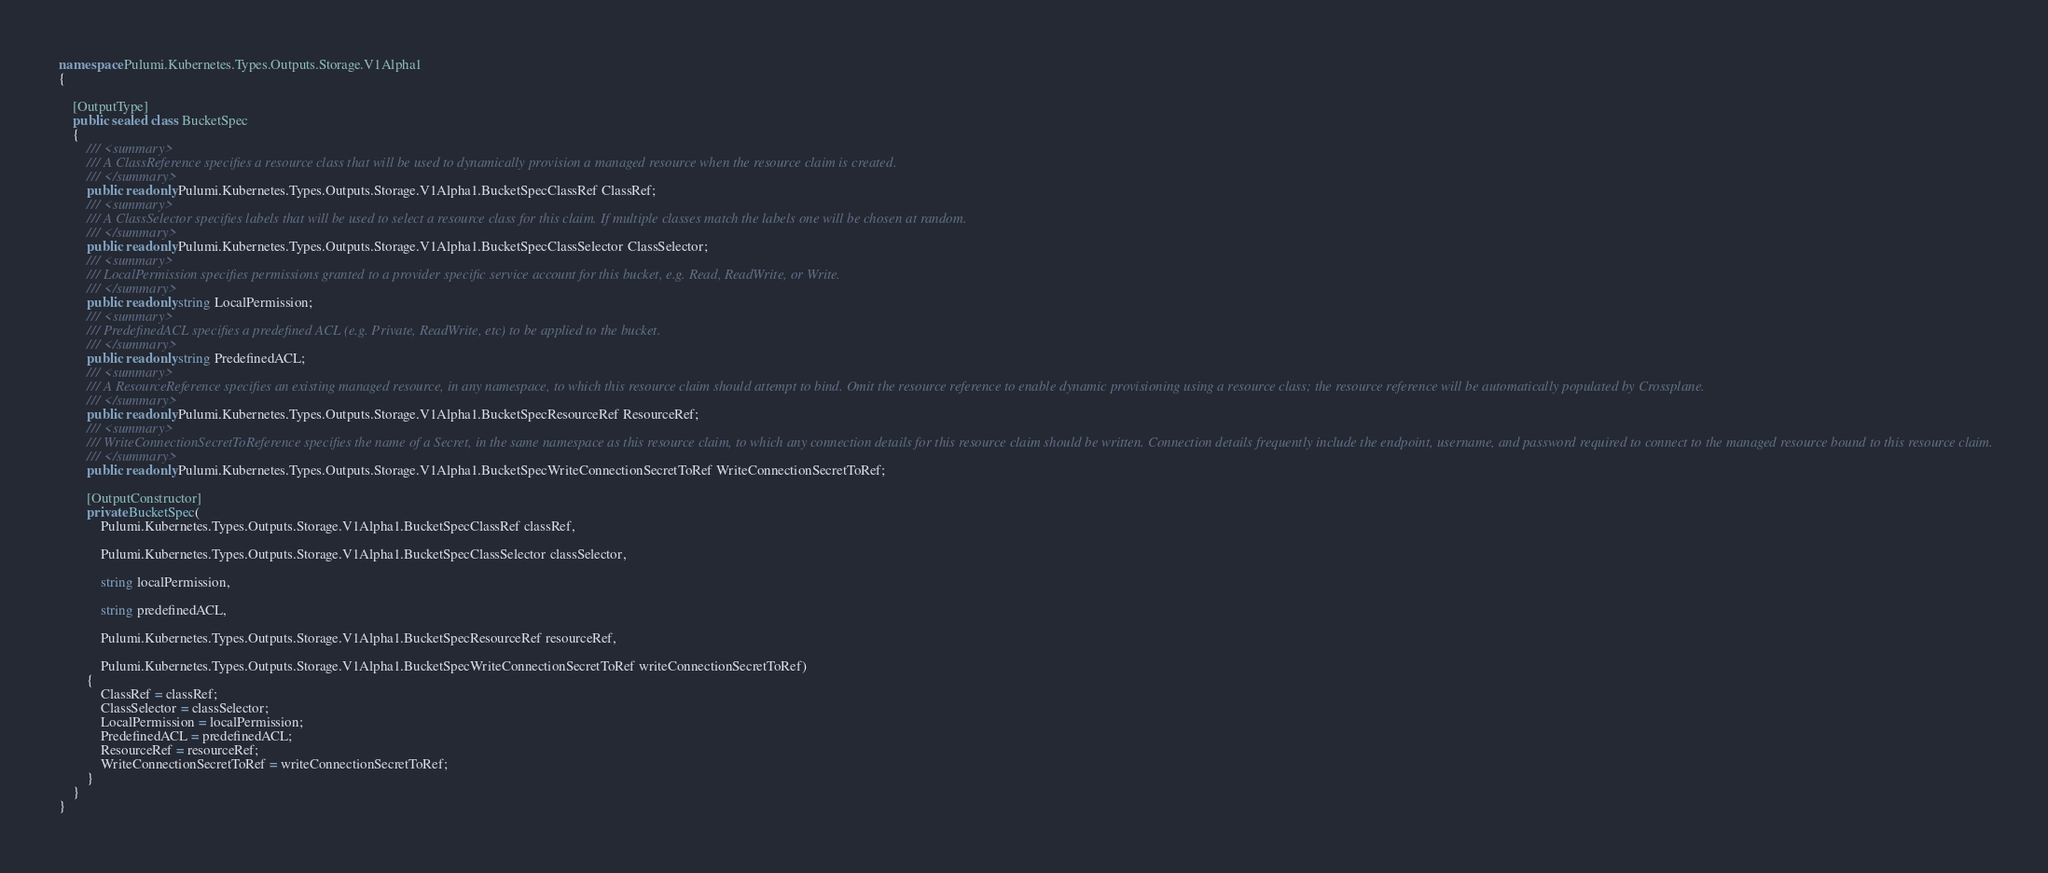<code> <loc_0><loc_0><loc_500><loc_500><_C#_>namespace Pulumi.Kubernetes.Types.Outputs.Storage.V1Alpha1
{

    [OutputType]
    public sealed class BucketSpec
    {
        /// <summary>
        /// A ClassReference specifies a resource class that will be used to dynamically provision a managed resource when the resource claim is created.
        /// </summary>
        public readonly Pulumi.Kubernetes.Types.Outputs.Storage.V1Alpha1.BucketSpecClassRef ClassRef;
        /// <summary>
        /// A ClassSelector specifies labels that will be used to select a resource class for this claim. If multiple classes match the labels one will be chosen at random.
        /// </summary>
        public readonly Pulumi.Kubernetes.Types.Outputs.Storage.V1Alpha1.BucketSpecClassSelector ClassSelector;
        /// <summary>
        /// LocalPermission specifies permissions granted to a provider specific service account for this bucket, e.g. Read, ReadWrite, or Write.
        /// </summary>
        public readonly string LocalPermission;
        /// <summary>
        /// PredefinedACL specifies a predefined ACL (e.g. Private, ReadWrite, etc) to be applied to the bucket.
        /// </summary>
        public readonly string PredefinedACL;
        /// <summary>
        /// A ResourceReference specifies an existing managed resource, in any namespace, to which this resource claim should attempt to bind. Omit the resource reference to enable dynamic provisioning using a resource class; the resource reference will be automatically populated by Crossplane.
        /// </summary>
        public readonly Pulumi.Kubernetes.Types.Outputs.Storage.V1Alpha1.BucketSpecResourceRef ResourceRef;
        /// <summary>
        /// WriteConnectionSecretToReference specifies the name of a Secret, in the same namespace as this resource claim, to which any connection details for this resource claim should be written. Connection details frequently include the endpoint, username, and password required to connect to the managed resource bound to this resource claim.
        /// </summary>
        public readonly Pulumi.Kubernetes.Types.Outputs.Storage.V1Alpha1.BucketSpecWriteConnectionSecretToRef WriteConnectionSecretToRef;

        [OutputConstructor]
        private BucketSpec(
            Pulumi.Kubernetes.Types.Outputs.Storage.V1Alpha1.BucketSpecClassRef classRef,

            Pulumi.Kubernetes.Types.Outputs.Storage.V1Alpha1.BucketSpecClassSelector classSelector,

            string localPermission,

            string predefinedACL,

            Pulumi.Kubernetes.Types.Outputs.Storage.V1Alpha1.BucketSpecResourceRef resourceRef,

            Pulumi.Kubernetes.Types.Outputs.Storage.V1Alpha1.BucketSpecWriteConnectionSecretToRef writeConnectionSecretToRef)
        {
            ClassRef = classRef;
            ClassSelector = classSelector;
            LocalPermission = localPermission;
            PredefinedACL = predefinedACL;
            ResourceRef = resourceRef;
            WriteConnectionSecretToRef = writeConnectionSecretToRef;
        }
    }
}
</code> 